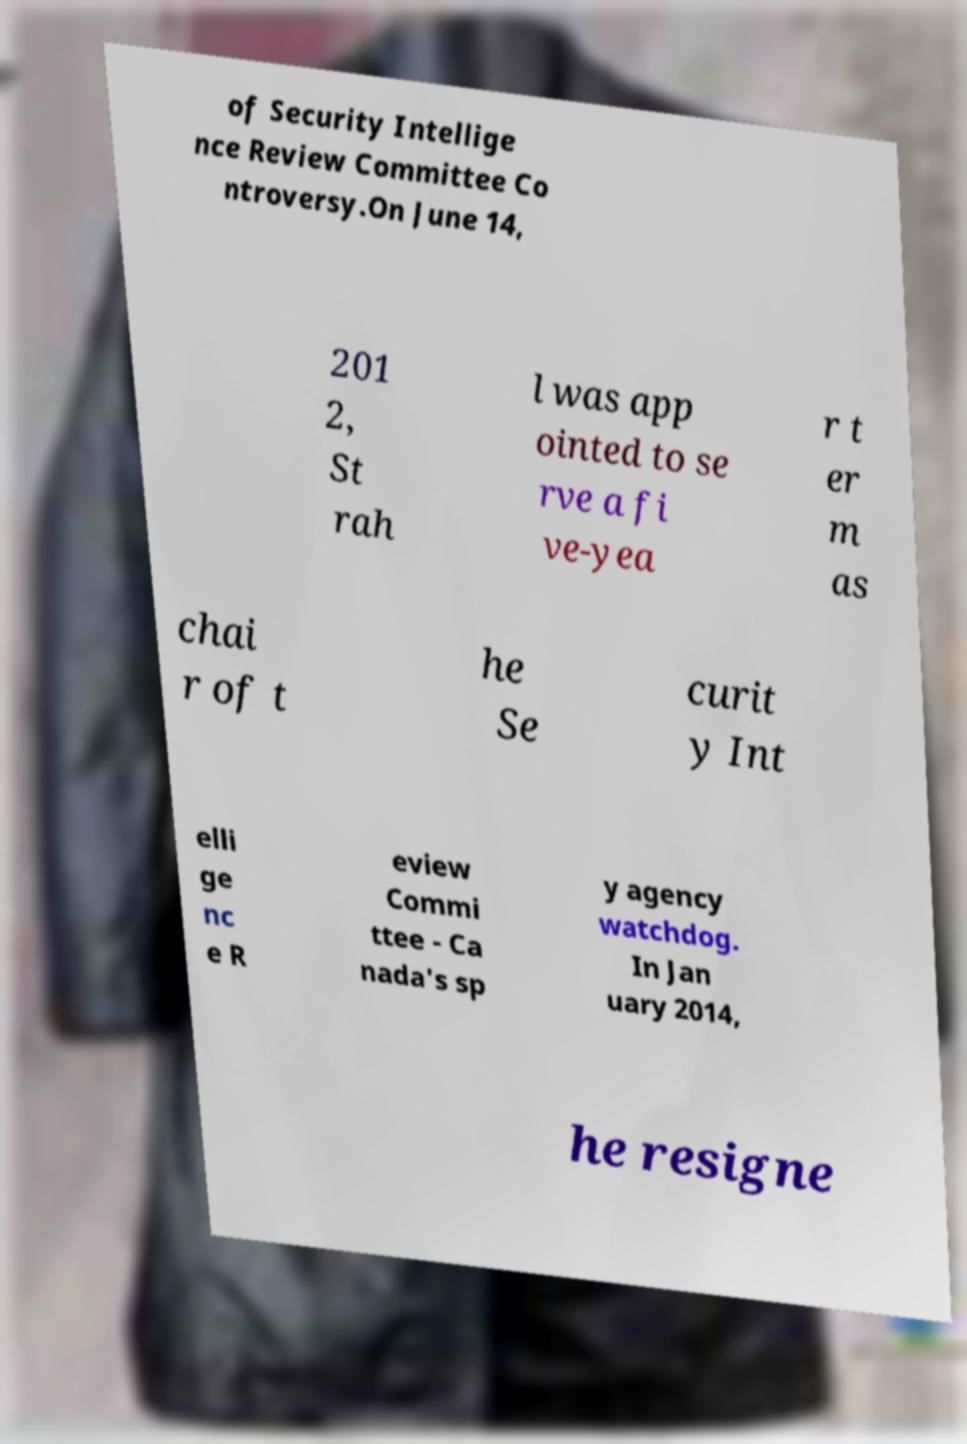What messages or text are displayed in this image? I need them in a readable, typed format. of Security Intellige nce Review Committee Co ntroversy.On June 14, 201 2, St rah l was app ointed to se rve a fi ve-yea r t er m as chai r of t he Se curit y Int elli ge nc e R eview Commi ttee - Ca nada's sp y agency watchdog. In Jan uary 2014, he resigne 